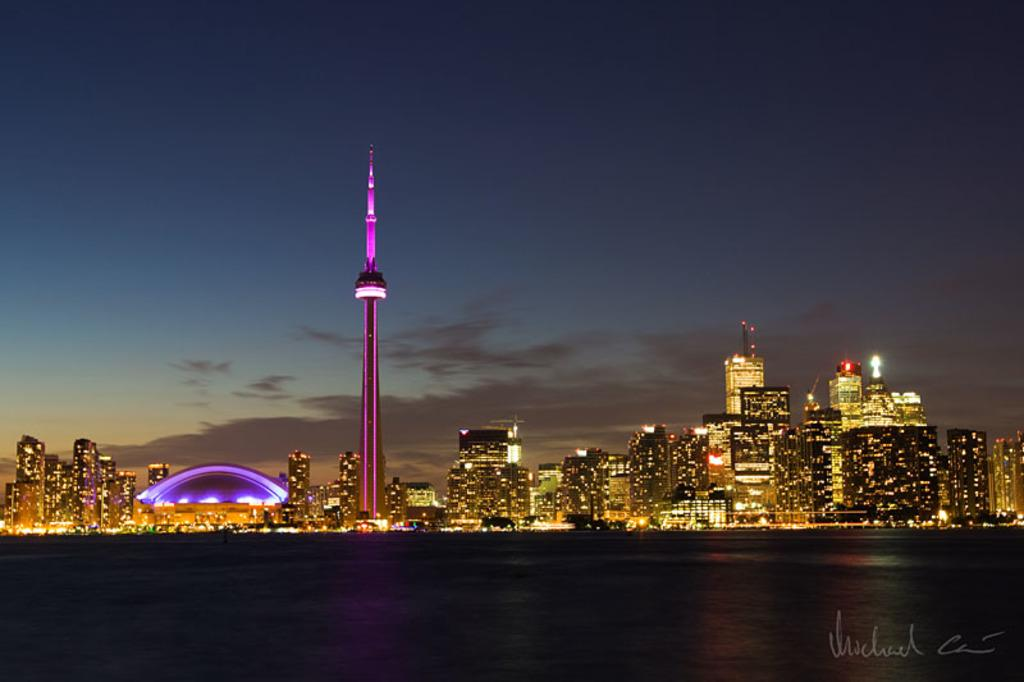What type of structures can be seen in the image? There are buildings in the image. What else is visible in the image besides the buildings? There are lights and clouds visible in the image. What part of the natural environment is visible in the image? The sky is visible in the image. Is there any indication of a watermark in the image? Yes, there is a watermark in the image. What type of straw is being used to drink the beef in the image? There is no straw or beef present in the image. 